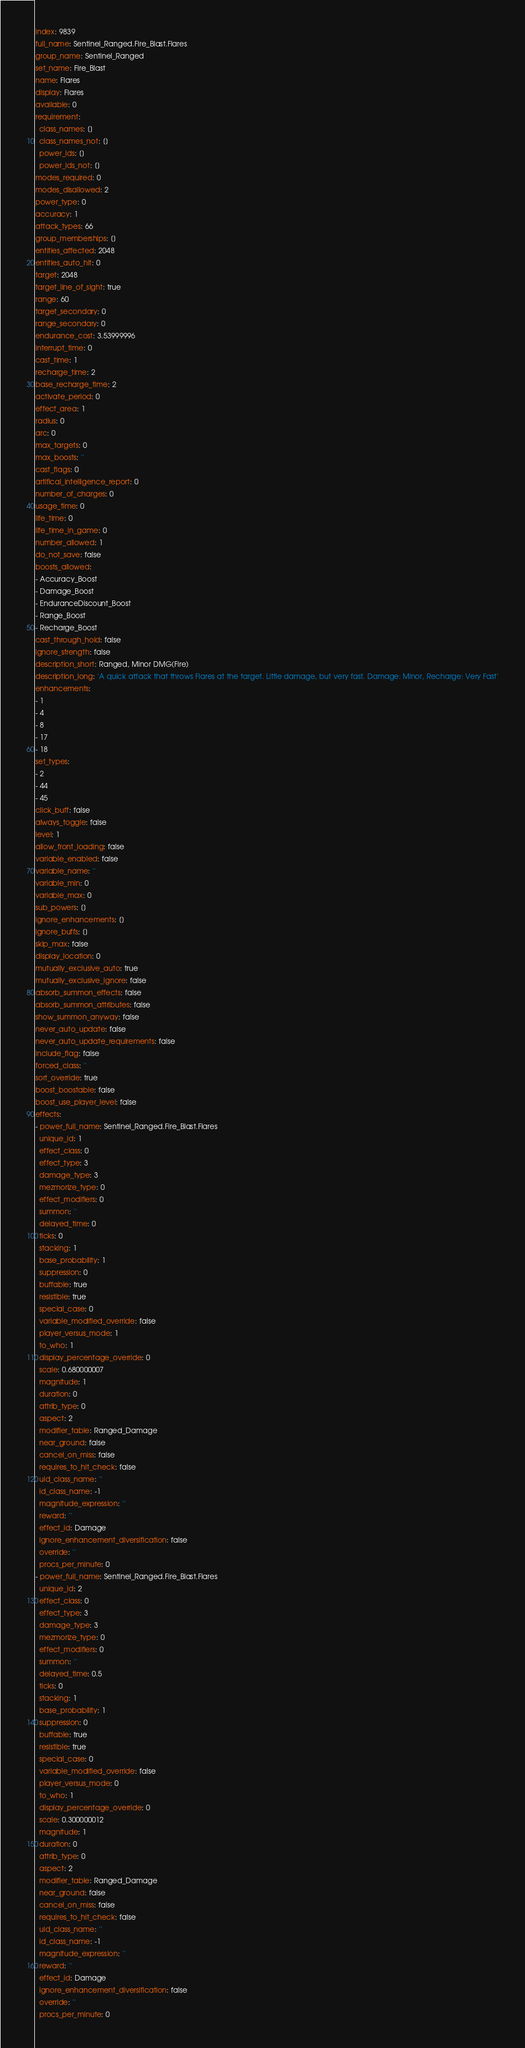<code> <loc_0><loc_0><loc_500><loc_500><_YAML_>index: 9839
full_name: Sentinel_Ranged.Fire_Blast.Flares
group_name: Sentinel_Ranged
set_name: Fire_Blast
name: Flares
display: Flares
available: 0
requirement:
  class_names: []
  class_names_not: []
  power_ids: []
  power_ids_not: []
modes_required: 0
modes_disallowed: 2
power_type: 0
accuracy: 1
attack_types: 66
group_memberships: []
entities_affected: 2048
entities_auto_hit: 0
target: 2048
target_line_of_sight: true
range: 60
target_secondary: 0
range_secondary: 0
endurance_cost: 3.53999996
interrupt_time: 0
cast_time: 1
recharge_time: 2
base_recharge_time: 2
activate_period: 0
effect_area: 1
radius: 0
arc: 0
max_targets: 0
max_boosts: ''
cast_flags: 0
artifical_intelligence_report: 0
number_of_charges: 0
usage_time: 0
life_time: 0
life_time_in_game: 0
number_allowed: 1
do_not_save: false
boosts_allowed:
- Accuracy_Boost
- Damage_Boost
- EnduranceDiscount_Boost
- Range_Boost
- Recharge_Boost
cast_through_hold: false
ignore_strength: false
description_short: Ranged, Minor DMG(Fire)
description_long: 'A quick attack that throws Flares at the target. Little damage, but very fast. Damage: Minor, Recharge: Very Fast'
enhancements:
- 1
- 4
- 8
- 17
- 18
set_types:
- 2
- 44
- 45
click_buff: false
always_toggle: false
level: 1
allow_front_loading: false
variable_enabled: false
variable_name: ''
variable_min: 0
variable_max: 0
sub_powers: []
ignore_enhancements: []
ignore_buffs: []
skip_max: false
display_location: 0
mutually_exclusive_auto: true
mutually_exclusive_ignore: false
absorb_summon_effects: false
absorb_summon_attributes: false
show_summon_anyway: false
never_auto_update: false
never_auto_update_requirements: false
include_flag: false
forced_class: ''
sort_override: true
boost_boostable: false
boost_use_player_level: false
effects:
- power_full_name: Sentinel_Ranged.Fire_Blast.Flares
  unique_id: 1
  effect_class: 0
  effect_type: 3
  damage_type: 3
  mezmorize_type: 0
  effect_modifiers: 0
  summon: ''
  delayed_time: 0
  ticks: 0
  stacking: 1
  base_probability: 1
  suppression: 0
  buffable: true
  resistible: true
  special_case: 0
  variable_modified_override: false
  player_versus_mode: 1
  to_who: 1
  display_percentage_override: 0
  scale: 0.680000007
  magnitude: 1
  duration: 0
  attrib_type: 0
  aspect: 2
  modifier_table: Ranged_Damage
  near_ground: false
  cancel_on_miss: false
  requires_to_hit_check: false
  uid_class_name: ''
  id_class_name: -1
  magnitude_expression: ''
  reward: ''
  effect_id: Damage
  ignore_enhancement_diversification: false
  override: ''
  procs_per_minute: 0
- power_full_name: Sentinel_Ranged.Fire_Blast.Flares
  unique_id: 2
  effect_class: 0
  effect_type: 3
  damage_type: 3
  mezmorize_type: 0
  effect_modifiers: 0
  summon: ''
  delayed_time: 0.5
  ticks: 0
  stacking: 1
  base_probability: 1
  suppression: 0
  buffable: true
  resistible: true
  special_case: 0
  variable_modified_override: false
  player_versus_mode: 0
  to_who: 1
  display_percentage_override: 0
  scale: 0.300000012
  magnitude: 1
  duration: 0
  attrib_type: 0
  aspect: 2
  modifier_table: Ranged_Damage
  near_ground: false
  cancel_on_miss: false
  requires_to_hit_check: false
  uid_class_name: ''
  id_class_name: -1
  magnitude_expression: ''
  reward: ''
  effect_id: Damage
  ignore_enhancement_diversification: false
  override: ''
  procs_per_minute: 0</code> 